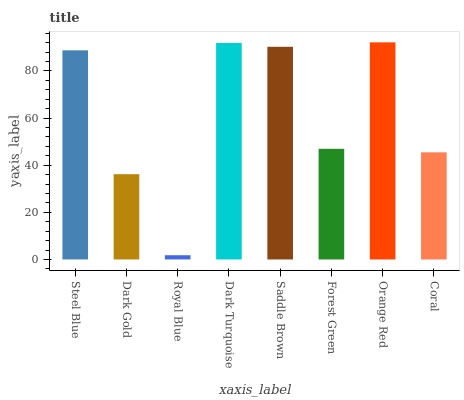Is Royal Blue the minimum?
Answer yes or no. Yes. Is Orange Red the maximum?
Answer yes or no. Yes. Is Dark Gold the minimum?
Answer yes or no. No. Is Dark Gold the maximum?
Answer yes or no. No. Is Steel Blue greater than Dark Gold?
Answer yes or no. Yes. Is Dark Gold less than Steel Blue?
Answer yes or no. Yes. Is Dark Gold greater than Steel Blue?
Answer yes or no. No. Is Steel Blue less than Dark Gold?
Answer yes or no. No. Is Steel Blue the high median?
Answer yes or no. Yes. Is Forest Green the low median?
Answer yes or no. Yes. Is Dark Turquoise the high median?
Answer yes or no. No. Is Royal Blue the low median?
Answer yes or no. No. 